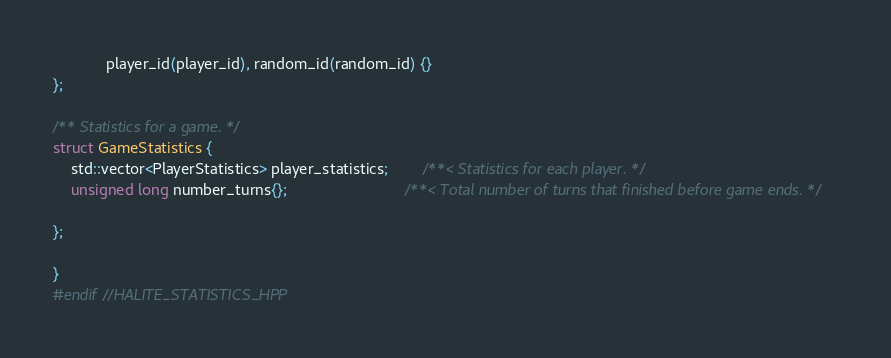Convert code to text. <code><loc_0><loc_0><loc_500><loc_500><_C++_>            player_id(player_id), random_id(random_id) {}
};

/** Statistics for a game. */
struct GameStatistics {
    std::vector<PlayerStatistics> player_statistics;        /**< Statistics for each player. */
    unsigned long number_turns{};                           /**< Total number of turns that finished before game ends. */

};

}
#endif //HALITE_STATISTICS_HPP
</code> 